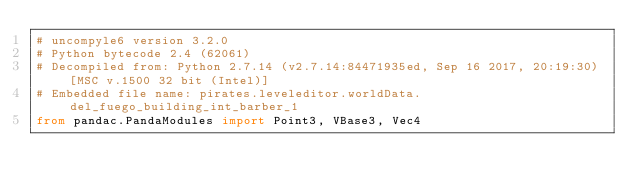Convert code to text. <code><loc_0><loc_0><loc_500><loc_500><_Python_># uncompyle6 version 3.2.0
# Python bytecode 2.4 (62061)
# Decompiled from: Python 2.7.14 (v2.7.14:84471935ed, Sep 16 2017, 20:19:30) [MSC v.1500 32 bit (Intel)]
# Embedded file name: pirates.leveleditor.worldData.del_fuego_building_int_barber_1
from pandac.PandaModules import Point3, VBase3, Vec4</code> 